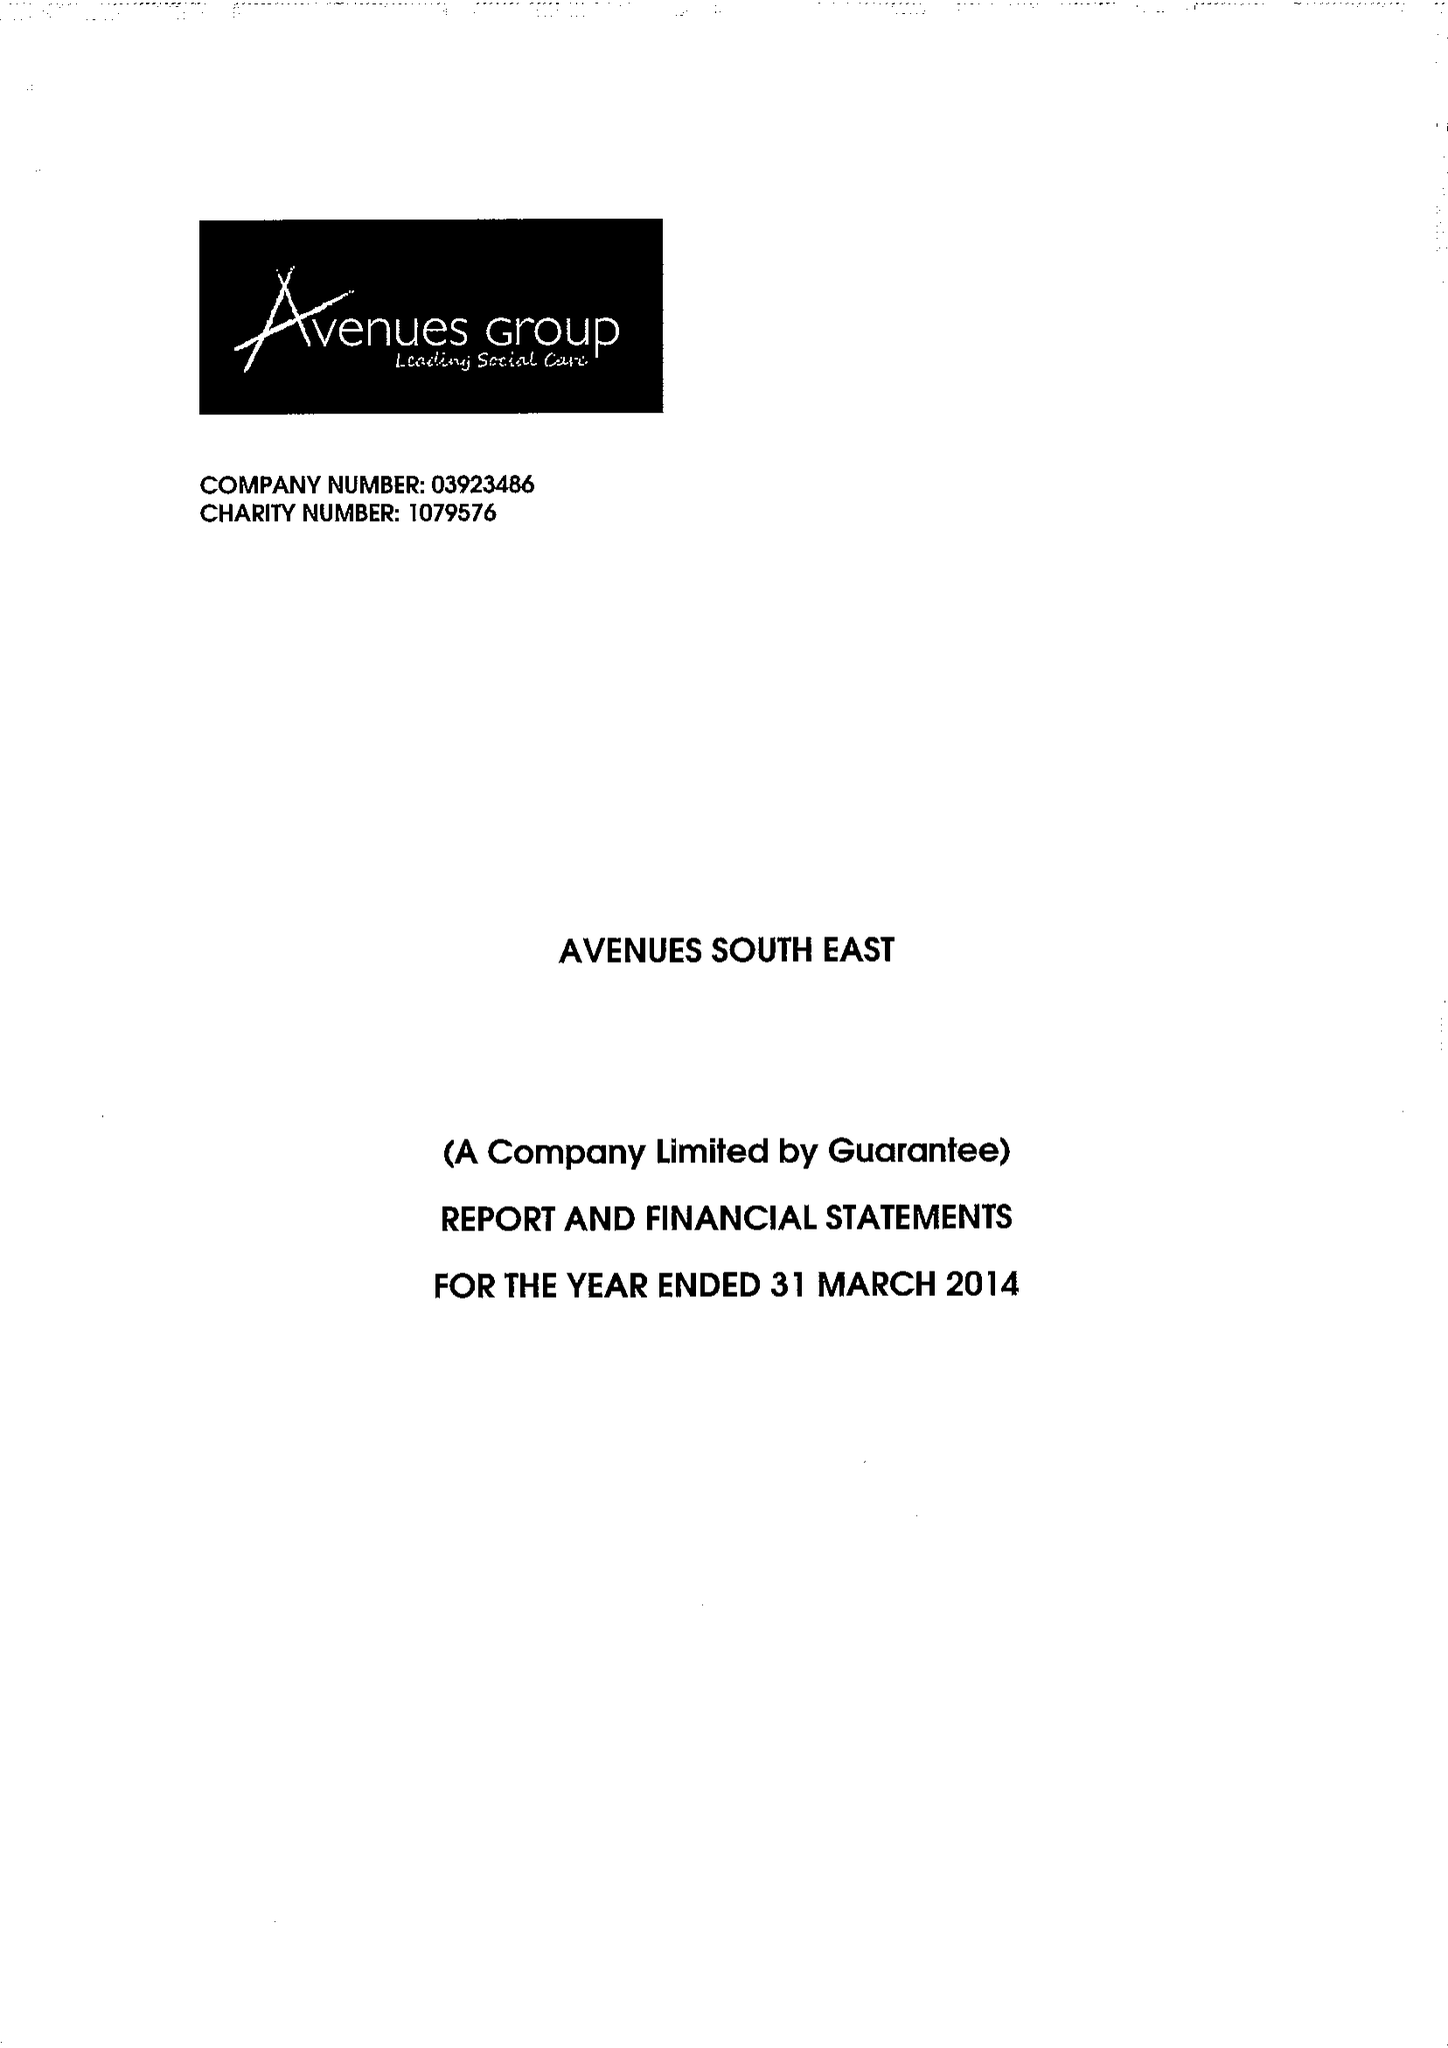What is the value for the address__street_line?
Answer the question using a single word or phrase. 1 MAIDSTONE ROAD 